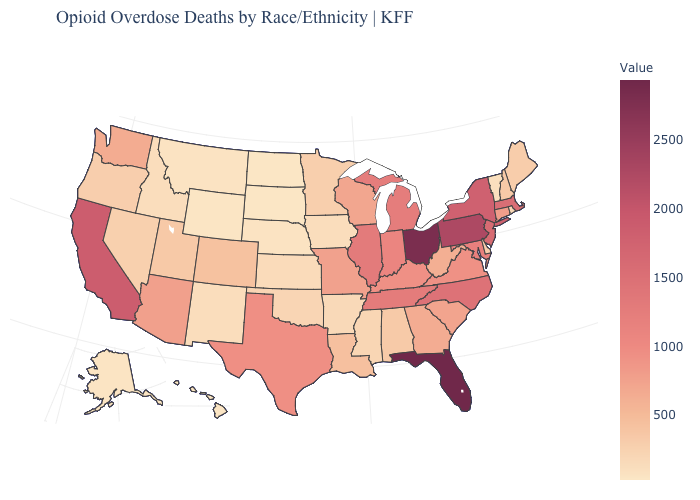Does the map have missing data?
Write a very short answer. No. Among the states that border Missouri , which have the lowest value?
Write a very short answer. Nebraska. Does Idaho have a lower value than Missouri?
Give a very brief answer. Yes. 